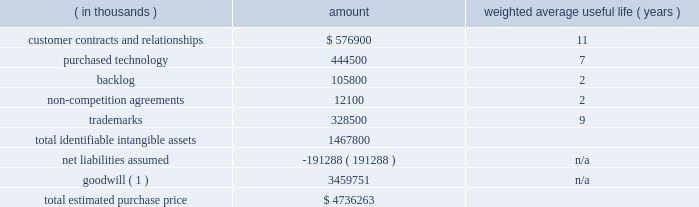Table of contents adobe inc .
Notes to consolidated financial statements ( continued ) the table below represents the preliminary purchase price allocation to the acquired net tangible and intangible assets of marketo based on their estimated fair values as of the acquisition date and the associated estimated useful lives at that date .
The fair values assigned to assets acquired and liabilities assumed are based on management 2019s best estimates and assumptions as of the reporting date and are considered preliminary pending finalization of valuation analyses pertaining to intangible assets acquired , deferred revenue and tax liabilities assumed including the calculation of deferred tax assets and liabilities .
( in thousands ) amount weighted average useful life ( years ) .
_________________________________________ ( 1 ) non-deductible for tax-purposes .
Identifiable intangible assets 2014customer relationships consist of marketo 2019s contractual relationships and customer loyalty related to their enterprise and commercial customers as well as technology partner relationships .
The estimated fair value of the customer contracts and relationships was determined based on projected cash flows attributable to the asset .
Purchased technology acquired primarily consists of marketo 2019s cloud-based engagement marketing software platform .
The estimated fair value of the purchased technology was determined based on the expected future cost savings resulting from ownership of the asset .
Backlog relates to subscription contracts and professional services .
Non-compete agreements include agreements with key marketo employees that preclude them from competing against marketo for a period of two years from the acquisition date .
Trademarks include the marketo trade name , which is well known in the marketing ecosystem .
We amortize the fair value of these intangible assets on a straight-line basis over their respective estimated useful lives .
Goodwill 2014approximately $ 3.46 billion has been allocated to goodwill , and has been allocated in full to the digital experience reportable segment .
Goodwill represents the excess of the purchase price over the fair value of the underlying acquired net tangible and intangible assets .
The factors that contributed to the recognition of goodwill included securing buyer-specific synergies that increase revenue and profits and are not otherwise available to a marketplace participant , acquiring a talented workforce and cost savings opportunities .
Net liabilities assumed 2014marketo 2019s tangible assets and liabilities as of october 31 , 2018 were reviewed and adjusted to their fair value as necessary .
The net liabilities assumed included , among other items , $ 100.1 million in accrued expenses , $ 74.8 million in deferred revenue and $ 182.6 million in deferred tax liabilities , which were partially offset by $ 54.9 million in cash and cash equivalents and $ 72.4 million in trade receivables acquired .
Deferred revenue 2014included in net liabilities assumed is marketo 2019s deferred revenue which represents advance payments from customers related to subscription contracts and professional services .
We estimated our obligation related to the deferred revenue using the cost build-up approach .
The cost build-up approach determines fair value by estimating the direct and indirect costs related to supporting the obligation plus an assumed operating margin .
The sum of the costs and assumed operating profit approximates , in theory , the amount that marketo would be required to pay a third party to assume the obligation .
The estimated costs to fulfill the obligation were based on the near-term projected cost structure for subscription and professional services .
As a result , we recorded an adjustment to reduce marketo 2019s carrying value of deferred revenue to $ 74.8 million , which represents our estimate of the fair value of the contractual obligations assumed based on a preliminary valuation. .
Goodwill is what percent of total estimated purchase price? 
Computations: (3459751 / 4736263)
Answer: 0.73048. 